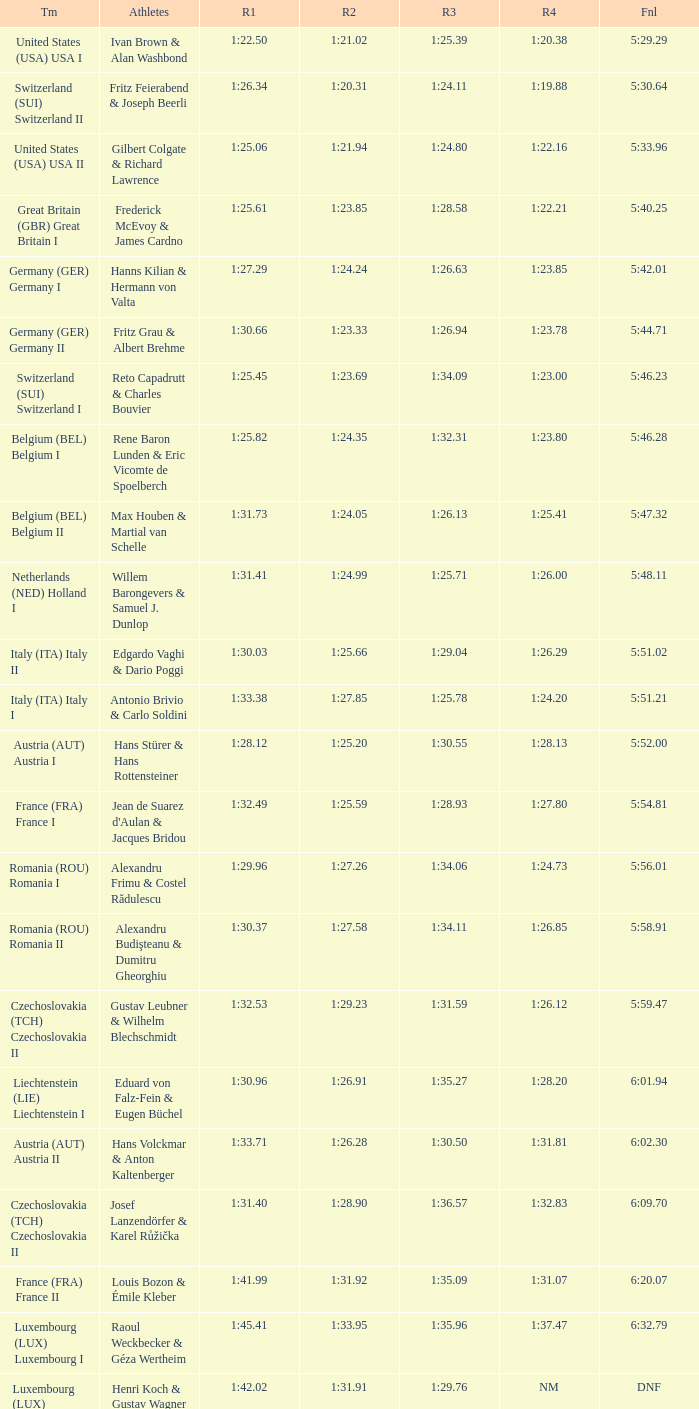Which Run 4 has a Run 1 of 1:25.82? 1:23.80. 